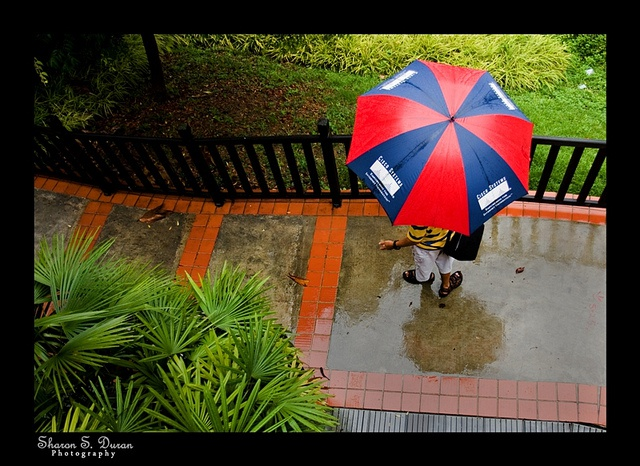Describe the objects in this image and their specific colors. I can see umbrella in black, red, navy, lightpink, and blue tones, people in black, darkgray, gray, and olive tones, and backpack in black, darkgray, gray, and olive tones in this image. 